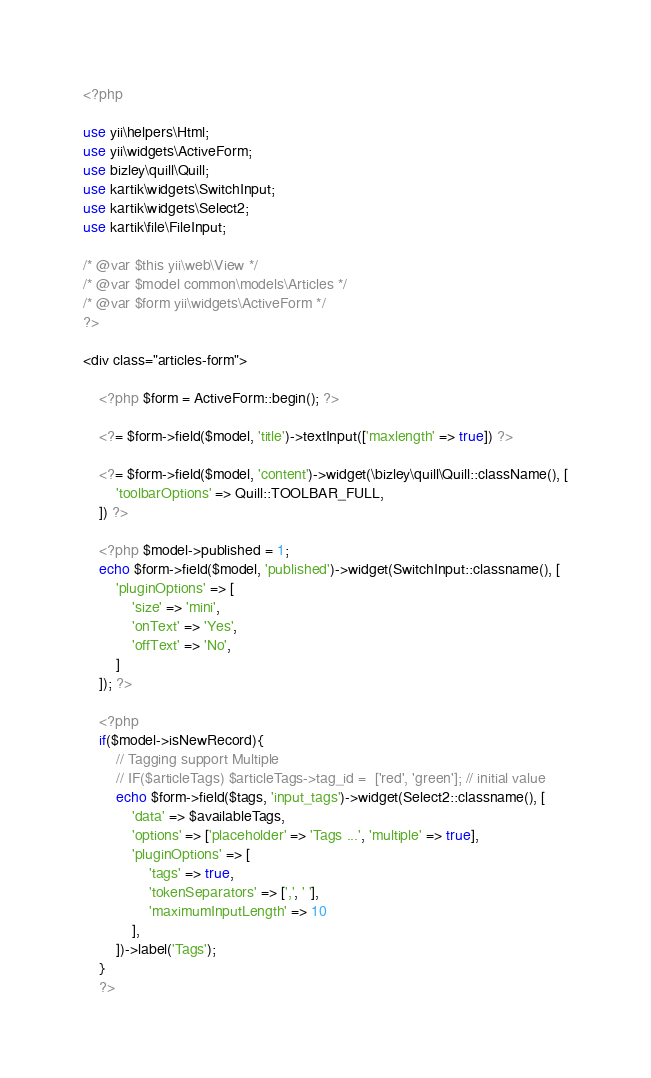<code> <loc_0><loc_0><loc_500><loc_500><_PHP_><?php

use yii\helpers\Html;
use yii\widgets\ActiveForm;
use bizley\quill\Quill;
use kartik\widgets\SwitchInput;
use kartik\widgets\Select2;
use kartik\file\FileInput;

/* @var $this yii\web\View */
/* @var $model common\models\Articles */
/* @var $form yii\widgets\ActiveForm */
?>

<div class="articles-form">

    <?php $form = ActiveForm::begin(); ?>

    <?= $form->field($model, 'title')->textInput(['maxlength' => true]) ?>

    <?= $form->field($model, 'content')->widget(\bizley\quill\Quill::className(), [
        'toolbarOptions' => Quill::TOOLBAR_FULL,
    ]) ?>

    <?php $model->published = 1;
    echo $form->field($model, 'published')->widget(SwitchInput::classname(), [
        'pluginOptions' => [
            'size' => 'mini',
            'onText' => 'Yes',
            'offText' => 'No',
        ]        
    ]); ?>

    <?php
    if($model->isNewRecord){
        // Tagging support Multiple
        // IF($articleTags) $articleTags->tag_id =  ['red', 'green']; // initial value
        echo $form->field($tags, 'input_tags')->widget(Select2::classname(), [
            'data' => $availableTags,
            'options' => ['placeholder' => 'Tags ...', 'multiple' => true],
            'pluginOptions' => [
                'tags' => true,
                'tokenSeparators' => [',', ' '],
                'maximumInputLength' => 10
            ],
        ])->label('Tags');
    }
    ?>
</code> 